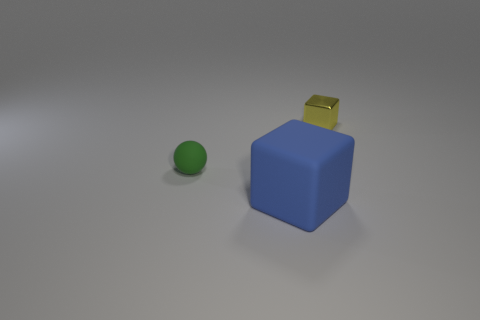Add 3 large blue matte things. How many objects exist? 6 Subtract all blocks. How many objects are left? 1 Subtract all big green metallic cylinders. Subtract all yellow metallic blocks. How many objects are left? 2 Add 3 small green balls. How many small green balls are left? 4 Add 1 red metal cylinders. How many red metal cylinders exist? 1 Subtract 0 red spheres. How many objects are left? 3 